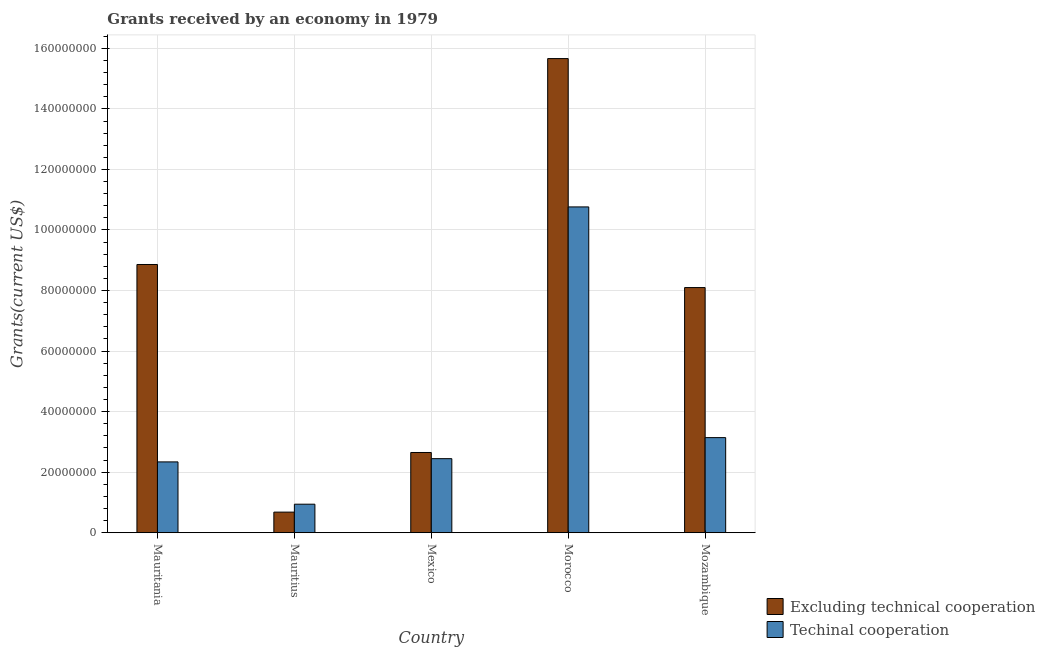How many different coloured bars are there?
Make the answer very short. 2. Are the number of bars on each tick of the X-axis equal?
Make the answer very short. Yes. How many bars are there on the 2nd tick from the right?
Offer a very short reply. 2. What is the label of the 1st group of bars from the left?
Give a very brief answer. Mauritania. What is the amount of grants received(including technical cooperation) in Morocco?
Your answer should be very brief. 1.08e+08. Across all countries, what is the maximum amount of grants received(excluding technical cooperation)?
Provide a short and direct response. 1.57e+08. Across all countries, what is the minimum amount of grants received(including technical cooperation)?
Provide a short and direct response. 9.42e+06. In which country was the amount of grants received(including technical cooperation) maximum?
Your response must be concise. Morocco. In which country was the amount of grants received(including technical cooperation) minimum?
Your response must be concise. Mauritius. What is the total amount of grants received(including technical cooperation) in the graph?
Keep it short and to the point. 1.96e+08. What is the difference between the amount of grants received(including technical cooperation) in Mexico and that in Mozambique?
Offer a terse response. -6.95e+06. What is the difference between the amount of grants received(excluding technical cooperation) in Morocco and the amount of grants received(including technical cooperation) in Mozambique?
Offer a very short reply. 1.25e+08. What is the average amount of grants received(including technical cooperation) per country?
Ensure brevity in your answer.  3.93e+07. What is the difference between the amount of grants received(including technical cooperation) and amount of grants received(excluding technical cooperation) in Mexico?
Provide a short and direct response. -2.04e+06. What is the ratio of the amount of grants received(including technical cooperation) in Mauritius to that in Mozambique?
Provide a succinct answer. 0.3. Is the amount of grants received(including technical cooperation) in Mauritius less than that in Morocco?
Provide a short and direct response. Yes. Is the difference between the amount of grants received(excluding technical cooperation) in Mexico and Morocco greater than the difference between the amount of grants received(including technical cooperation) in Mexico and Morocco?
Offer a terse response. No. What is the difference between the highest and the second highest amount of grants received(excluding technical cooperation)?
Ensure brevity in your answer.  6.80e+07. What is the difference between the highest and the lowest amount of grants received(including technical cooperation)?
Ensure brevity in your answer.  9.82e+07. In how many countries, is the amount of grants received(including technical cooperation) greater than the average amount of grants received(including technical cooperation) taken over all countries?
Offer a terse response. 1. What does the 1st bar from the left in Mauritania represents?
Your response must be concise. Excluding technical cooperation. What does the 2nd bar from the right in Morocco represents?
Provide a succinct answer. Excluding technical cooperation. How many countries are there in the graph?
Your answer should be very brief. 5. Are the values on the major ticks of Y-axis written in scientific E-notation?
Offer a terse response. No. Does the graph contain grids?
Offer a terse response. Yes. How many legend labels are there?
Your response must be concise. 2. How are the legend labels stacked?
Your answer should be very brief. Vertical. What is the title of the graph?
Your answer should be very brief. Grants received by an economy in 1979. What is the label or title of the X-axis?
Offer a very short reply. Country. What is the label or title of the Y-axis?
Keep it short and to the point. Grants(current US$). What is the Grants(current US$) of Excluding technical cooperation in Mauritania?
Give a very brief answer. 8.86e+07. What is the Grants(current US$) of Techinal cooperation in Mauritania?
Offer a terse response. 2.34e+07. What is the Grants(current US$) in Excluding technical cooperation in Mauritius?
Ensure brevity in your answer.  6.80e+06. What is the Grants(current US$) in Techinal cooperation in Mauritius?
Offer a terse response. 9.42e+06. What is the Grants(current US$) of Excluding technical cooperation in Mexico?
Ensure brevity in your answer.  2.65e+07. What is the Grants(current US$) of Techinal cooperation in Mexico?
Ensure brevity in your answer.  2.45e+07. What is the Grants(current US$) of Excluding technical cooperation in Morocco?
Provide a short and direct response. 1.57e+08. What is the Grants(current US$) of Techinal cooperation in Morocco?
Keep it short and to the point. 1.08e+08. What is the Grants(current US$) in Excluding technical cooperation in Mozambique?
Offer a terse response. 8.10e+07. What is the Grants(current US$) in Techinal cooperation in Mozambique?
Provide a short and direct response. 3.14e+07. Across all countries, what is the maximum Grants(current US$) in Excluding technical cooperation?
Make the answer very short. 1.57e+08. Across all countries, what is the maximum Grants(current US$) in Techinal cooperation?
Your answer should be compact. 1.08e+08. Across all countries, what is the minimum Grants(current US$) of Excluding technical cooperation?
Your answer should be very brief. 6.80e+06. Across all countries, what is the minimum Grants(current US$) of Techinal cooperation?
Your answer should be very brief. 9.42e+06. What is the total Grants(current US$) of Excluding technical cooperation in the graph?
Offer a very short reply. 3.60e+08. What is the total Grants(current US$) of Techinal cooperation in the graph?
Keep it short and to the point. 1.96e+08. What is the difference between the Grants(current US$) in Excluding technical cooperation in Mauritania and that in Mauritius?
Your answer should be very brief. 8.18e+07. What is the difference between the Grants(current US$) of Techinal cooperation in Mauritania and that in Mauritius?
Keep it short and to the point. 1.40e+07. What is the difference between the Grants(current US$) in Excluding technical cooperation in Mauritania and that in Mexico?
Offer a very short reply. 6.21e+07. What is the difference between the Grants(current US$) of Techinal cooperation in Mauritania and that in Mexico?
Your answer should be very brief. -1.07e+06. What is the difference between the Grants(current US$) of Excluding technical cooperation in Mauritania and that in Morocco?
Keep it short and to the point. -6.80e+07. What is the difference between the Grants(current US$) of Techinal cooperation in Mauritania and that in Morocco?
Provide a short and direct response. -8.42e+07. What is the difference between the Grants(current US$) in Excluding technical cooperation in Mauritania and that in Mozambique?
Your response must be concise. 7.62e+06. What is the difference between the Grants(current US$) of Techinal cooperation in Mauritania and that in Mozambique?
Provide a succinct answer. -8.02e+06. What is the difference between the Grants(current US$) of Excluding technical cooperation in Mauritius and that in Mexico?
Provide a short and direct response. -1.97e+07. What is the difference between the Grants(current US$) of Techinal cooperation in Mauritius and that in Mexico?
Your answer should be compact. -1.50e+07. What is the difference between the Grants(current US$) in Excluding technical cooperation in Mauritius and that in Morocco?
Make the answer very short. -1.50e+08. What is the difference between the Grants(current US$) of Techinal cooperation in Mauritius and that in Morocco?
Ensure brevity in your answer.  -9.82e+07. What is the difference between the Grants(current US$) of Excluding technical cooperation in Mauritius and that in Mozambique?
Ensure brevity in your answer.  -7.42e+07. What is the difference between the Grants(current US$) in Techinal cooperation in Mauritius and that in Mozambique?
Keep it short and to the point. -2.20e+07. What is the difference between the Grants(current US$) in Excluding technical cooperation in Mexico and that in Morocco?
Offer a very short reply. -1.30e+08. What is the difference between the Grants(current US$) in Techinal cooperation in Mexico and that in Morocco?
Ensure brevity in your answer.  -8.32e+07. What is the difference between the Grants(current US$) in Excluding technical cooperation in Mexico and that in Mozambique?
Your answer should be compact. -5.45e+07. What is the difference between the Grants(current US$) of Techinal cooperation in Mexico and that in Mozambique?
Ensure brevity in your answer.  -6.95e+06. What is the difference between the Grants(current US$) of Excluding technical cooperation in Morocco and that in Mozambique?
Make the answer very short. 7.56e+07. What is the difference between the Grants(current US$) in Techinal cooperation in Morocco and that in Mozambique?
Offer a very short reply. 7.62e+07. What is the difference between the Grants(current US$) in Excluding technical cooperation in Mauritania and the Grants(current US$) in Techinal cooperation in Mauritius?
Ensure brevity in your answer.  7.92e+07. What is the difference between the Grants(current US$) of Excluding technical cooperation in Mauritania and the Grants(current US$) of Techinal cooperation in Mexico?
Ensure brevity in your answer.  6.41e+07. What is the difference between the Grants(current US$) in Excluding technical cooperation in Mauritania and the Grants(current US$) in Techinal cooperation in Morocco?
Your response must be concise. -1.90e+07. What is the difference between the Grants(current US$) of Excluding technical cooperation in Mauritania and the Grants(current US$) of Techinal cooperation in Mozambique?
Provide a succinct answer. 5.72e+07. What is the difference between the Grants(current US$) of Excluding technical cooperation in Mauritius and the Grants(current US$) of Techinal cooperation in Mexico?
Your answer should be very brief. -1.77e+07. What is the difference between the Grants(current US$) of Excluding technical cooperation in Mauritius and the Grants(current US$) of Techinal cooperation in Morocco?
Your answer should be very brief. -1.01e+08. What is the difference between the Grants(current US$) in Excluding technical cooperation in Mauritius and the Grants(current US$) in Techinal cooperation in Mozambique?
Provide a short and direct response. -2.46e+07. What is the difference between the Grants(current US$) of Excluding technical cooperation in Mexico and the Grants(current US$) of Techinal cooperation in Morocco?
Your response must be concise. -8.11e+07. What is the difference between the Grants(current US$) in Excluding technical cooperation in Mexico and the Grants(current US$) in Techinal cooperation in Mozambique?
Your response must be concise. -4.91e+06. What is the difference between the Grants(current US$) in Excluding technical cooperation in Morocco and the Grants(current US$) in Techinal cooperation in Mozambique?
Offer a very short reply. 1.25e+08. What is the average Grants(current US$) of Excluding technical cooperation per country?
Your answer should be compact. 7.19e+07. What is the average Grants(current US$) of Techinal cooperation per country?
Ensure brevity in your answer.  3.93e+07. What is the difference between the Grants(current US$) of Excluding technical cooperation and Grants(current US$) of Techinal cooperation in Mauritania?
Give a very brief answer. 6.52e+07. What is the difference between the Grants(current US$) in Excluding technical cooperation and Grants(current US$) in Techinal cooperation in Mauritius?
Make the answer very short. -2.62e+06. What is the difference between the Grants(current US$) of Excluding technical cooperation and Grants(current US$) of Techinal cooperation in Mexico?
Keep it short and to the point. 2.04e+06. What is the difference between the Grants(current US$) in Excluding technical cooperation and Grants(current US$) in Techinal cooperation in Morocco?
Give a very brief answer. 4.90e+07. What is the difference between the Grants(current US$) of Excluding technical cooperation and Grants(current US$) of Techinal cooperation in Mozambique?
Ensure brevity in your answer.  4.96e+07. What is the ratio of the Grants(current US$) in Excluding technical cooperation in Mauritania to that in Mauritius?
Offer a terse response. 13.03. What is the ratio of the Grants(current US$) in Techinal cooperation in Mauritania to that in Mauritius?
Ensure brevity in your answer.  2.48. What is the ratio of the Grants(current US$) in Excluding technical cooperation in Mauritania to that in Mexico?
Give a very brief answer. 3.34. What is the ratio of the Grants(current US$) in Techinal cooperation in Mauritania to that in Mexico?
Your answer should be compact. 0.96. What is the ratio of the Grants(current US$) in Excluding technical cooperation in Mauritania to that in Morocco?
Your answer should be compact. 0.57. What is the ratio of the Grants(current US$) of Techinal cooperation in Mauritania to that in Morocco?
Your response must be concise. 0.22. What is the ratio of the Grants(current US$) of Excluding technical cooperation in Mauritania to that in Mozambique?
Keep it short and to the point. 1.09. What is the ratio of the Grants(current US$) in Techinal cooperation in Mauritania to that in Mozambique?
Your response must be concise. 0.74. What is the ratio of the Grants(current US$) in Excluding technical cooperation in Mauritius to that in Mexico?
Give a very brief answer. 0.26. What is the ratio of the Grants(current US$) in Techinal cooperation in Mauritius to that in Mexico?
Offer a terse response. 0.39. What is the ratio of the Grants(current US$) in Excluding technical cooperation in Mauritius to that in Morocco?
Keep it short and to the point. 0.04. What is the ratio of the Grants(current US$) in Techinal cooperation in Mauritius to that in Morocco?
Make the answer very short. 0.09. What is the ratio of the Grants(current US$) of Excluding technical cooperation in Mauritius to that in Mozambique?
Your answer should be compact. 0.08. What is the ratio of the Grants(current US$) of Techinal cooperation in Mauritius to that in Mozambique?
Your answer should be very brief. 0.3. What is the ratio of the Grants(current US$) in Excluding technical cooperation in Mexico to that in Morocco?
Your answer should be compact. 0.17. What is the ratio of the Grants(current US$) of Techinal cooperation in Mexico to that in Morocco?
Ensure brevity in your answer.  0.23. What is the ratio of the Grants(current US$) of Excluding technical cooperation in Mexico to that in Mozambique?
Provide a short and direct response. 0.33. What is the ratio of the Grants(current US$) of Techinal cooperation in Mexico to that in Mozambique?
Offer a very short reply. 0.78. What is the ratio of the Grants(current US$) of Excluding technical cooperation in Morocco to that in Mozambique?
Your response must be concise. 1.93. What is the ratio of the Grants(current US$) of Techinal cooperation in Morocco to that in Mozambique?
Make the answer very short. 3.43. What is the difference between the highest and the second highest Grants(current US$) in Excluding technical cooperation?
Provide a short and direct response. 6.80e+07. What is the difference between the highest and the second highest Grants(current US$) of Techinal cooperation?
Give a very brief answer. 7.62e+07. What is the difference between the highest and the lowest Grants(current US$) in Excluding technical cooperation?
Give a very brief answer. 1.50e+08. What is the difference between the highest and the lowest Grants(current US$) in Techinal cooperation?
Offer a terse response. 9.82e+07. 